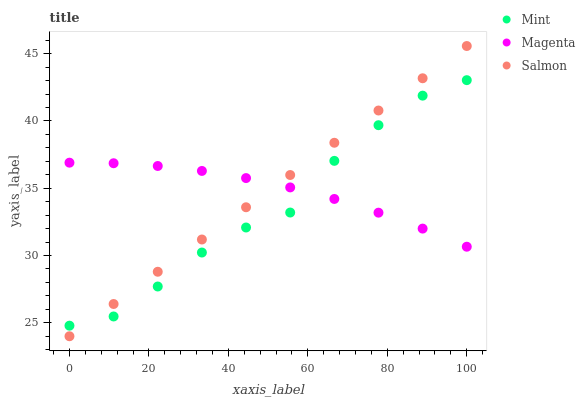Does Mint have the minimum area under the curve?
Answer yes or no. Yes. Does Magenta have the maximum area under the curve?
Answer yes or no. Yes. Does Magenta have the minimum area under the curve?
Answer yes or no. No. Does Mint have the maximum area under the curve?
Answer yes or no. No. Is Salmon the smoothest?
Answer yes or no. Yes. Is Mint the roughest?
Answer yes or no. Yes. Is Magenta the smoothest?
Answer yes or no. No. Is Magenta the roughest?
Answer yes or no. No. Does Salmon have the lowest value?
Answer yes or no. Yes. Does Mint have the lowest value?
Answer yes or no. No. Does Salmon have the highest value?
Answer yes or no. Yes. Does Mint have the highest value?
Answer yes or no. No. Does Salmon intersect Magenta?
Answer yes or no. Yes. Is Salmon less than Magenta?
Answer yes or no. No. Is Salmon greater than Magenta?
Answer yes or no. No. 